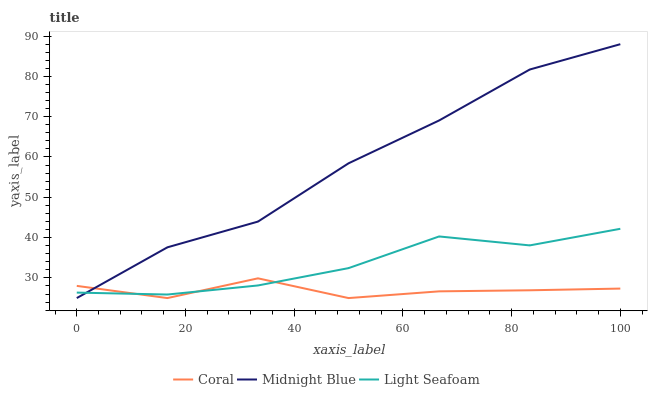Does Coral have the minimum area under the curve?
Answer yes or no. Yes. Does Midnight Blue have the maximum area under the curve?
Answer yes or no. Yes. Does Light Seafoam have the minimum area under the curve?
Answer yes or no. No. Does Light Seafoam have the maximum area under the curve?
Answer yes or no. No. Is Light Seafoam the smoothest?
Answer yes or no. Yes. Is Midnight Blue the roughest?
Answer yes or no. Yes. Is Midnight Blue the smoothest?
Answer yes or no. No. Is Light Seafoam the roughest?
Answer yes or no. No. Does Coral have the lowest value?
Answer yes or no. Yes. Does Light Seafoam have the lowest value?
Answer yes or no. No. Does Midnight Blue have the highest value?
Answer yes or no. Yes. Does Light Seafoam have the highest value?
Answer yes or no. No. Does Midnight Blue intersect Light Seafoam?
Answer yes or no. Yes. Is Midnight Blue less than Light Seafoam?
Answer yes or no. No. Is Midnight Blue greater than Light Seafoam?
Answer yes or no. No. 